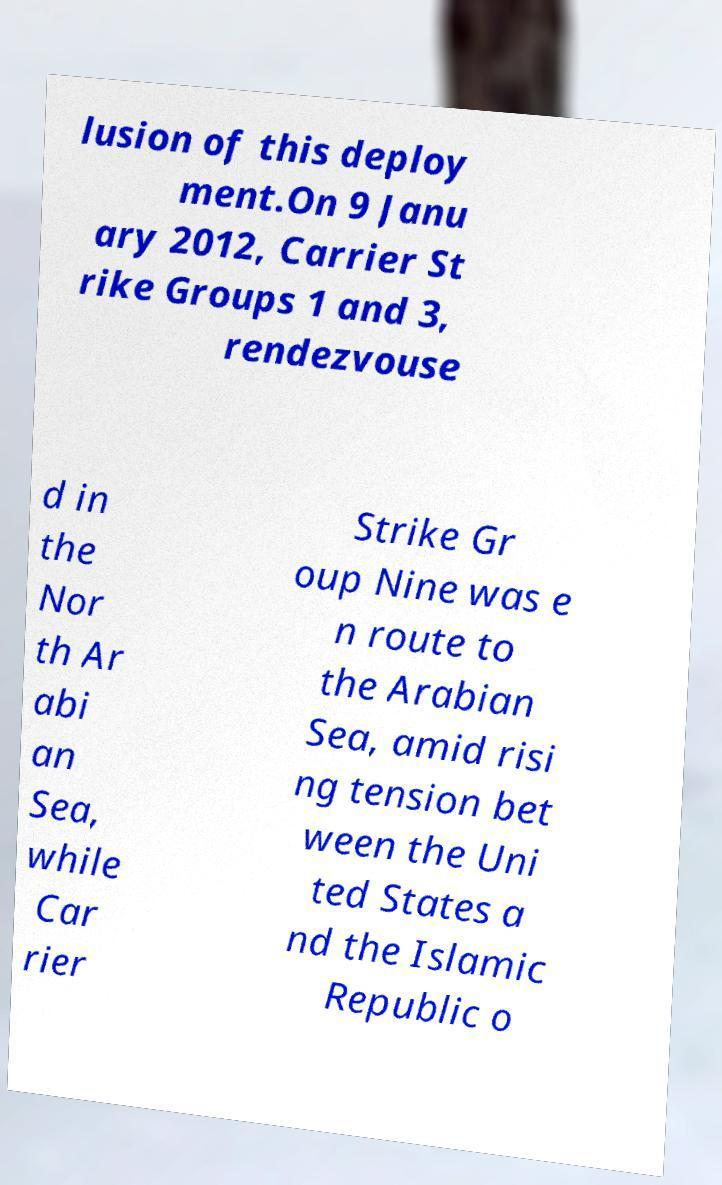Could you extract and type out the text from this image? lusion of this deploy ment.On 9 Janu ary 2012, Carrier St rike Groups 1 and 3, rendezvouse d in the Nor th Ar abi an Sea, while Car rier Strike Gr oup Nine was e n route to the Arabian Sea, amid risi ng tension bet ween the Uni ted States a nd the Islamic Republic o 